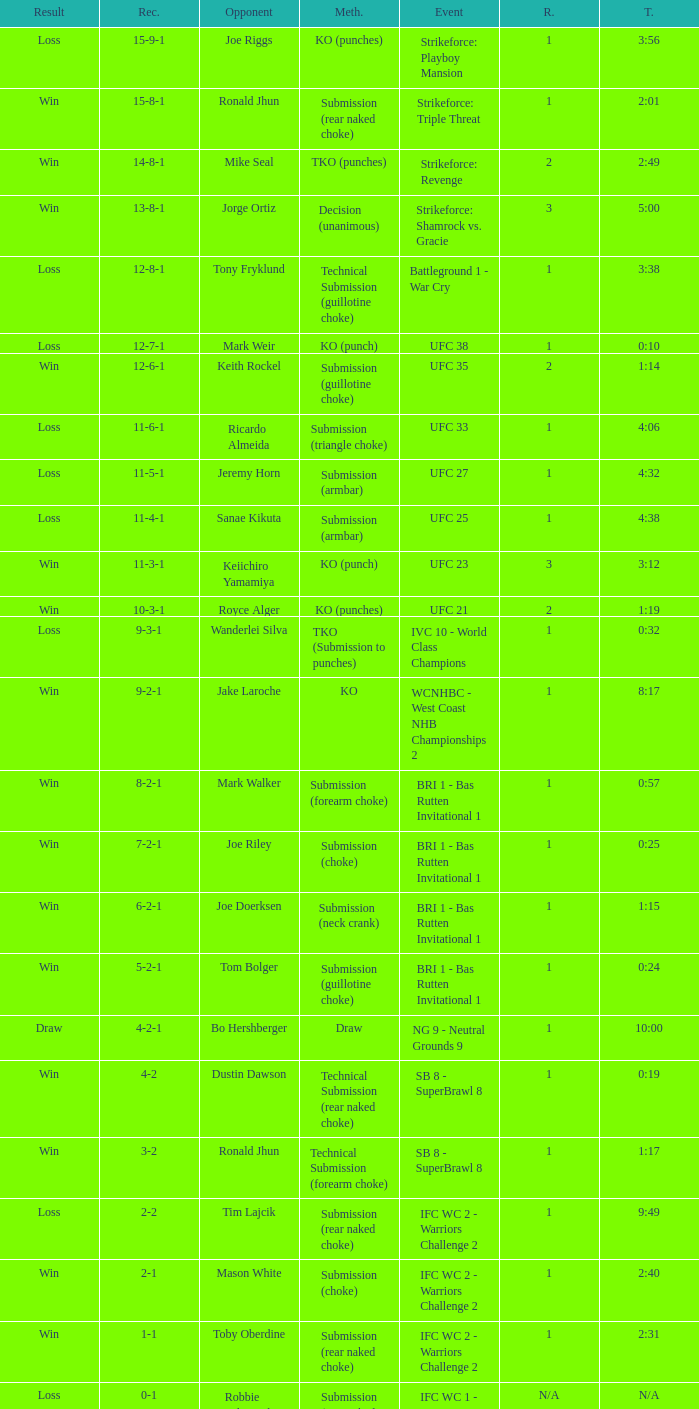What was the record when the method of resolution was KO? 9-2-1. 